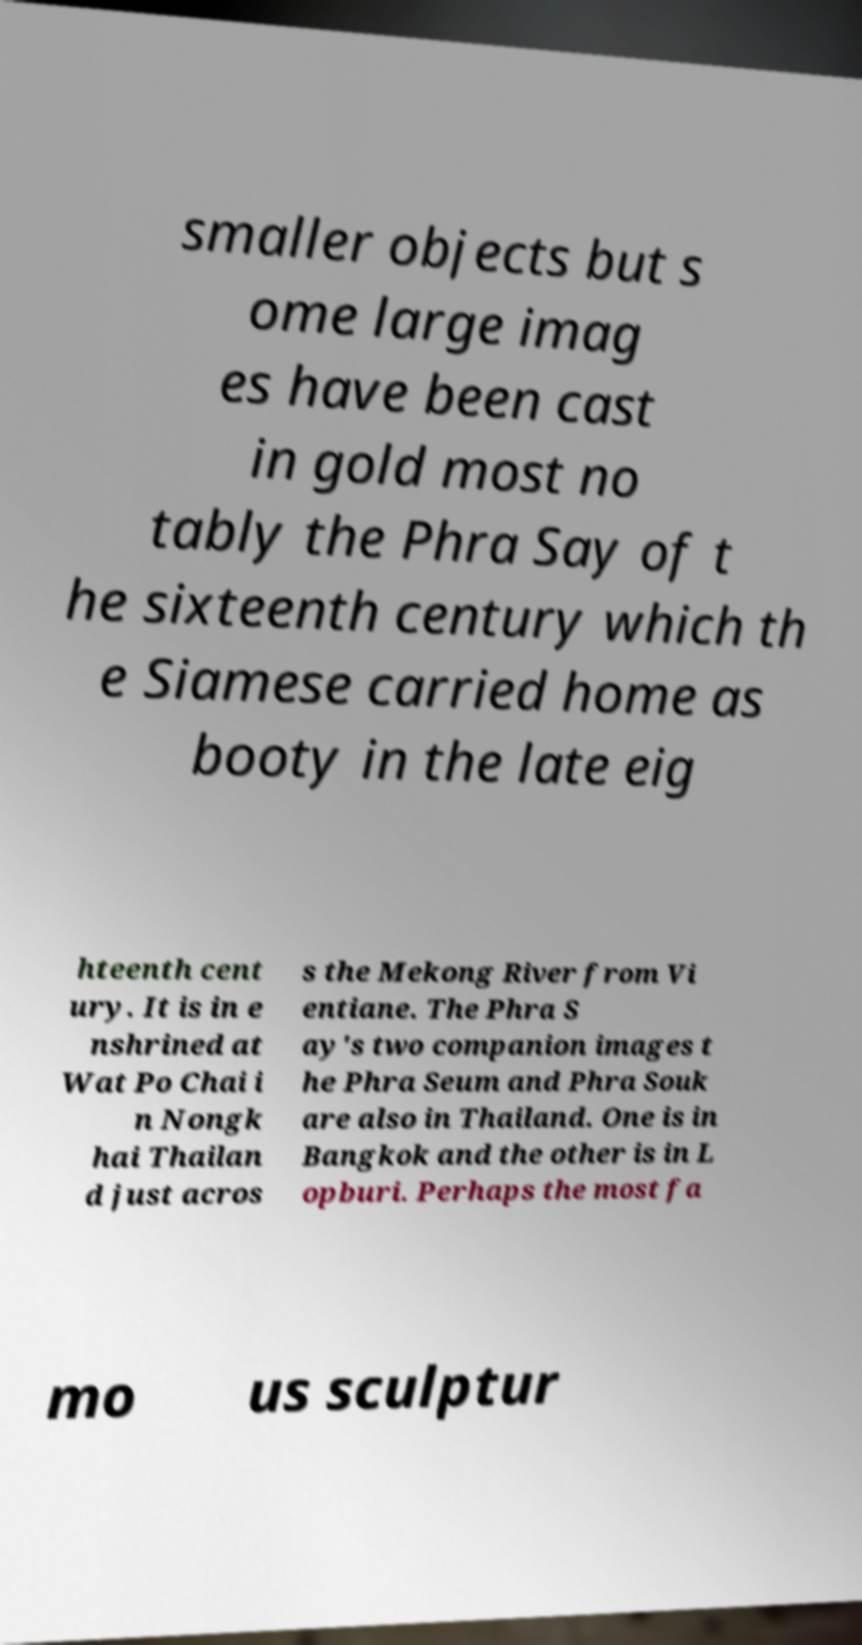There's text embedded in this image that I need extracted. Can you transcribe it verbatim? smaller objects but s ome large imag es have been cast in gold most no tably the Phra Say of t he sixteenth century which th e Siamese carried home as booty in the late eig hteenth cent ury. It is in e nshrined at Wat Po Chai i n Nongk hai Thailan d just acros s the Mekong River from Vi entiane. The Phra S ay's two companion images t he Phra Seum and Phra Souk are also in Thailand. One is in Bangkok and the other is in L opburi. Perhaps the most fa mo us sculptur 